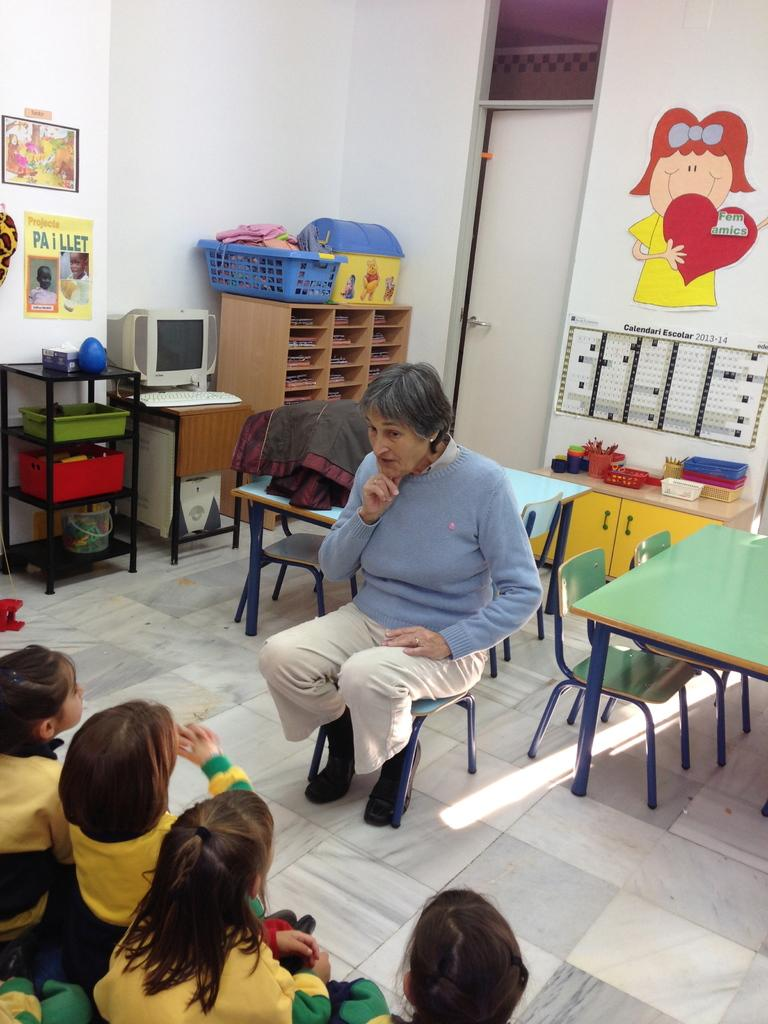<image>
Describe the image concisely. A woman sits in front of a poster marked "Calendair Escolar 2013." 